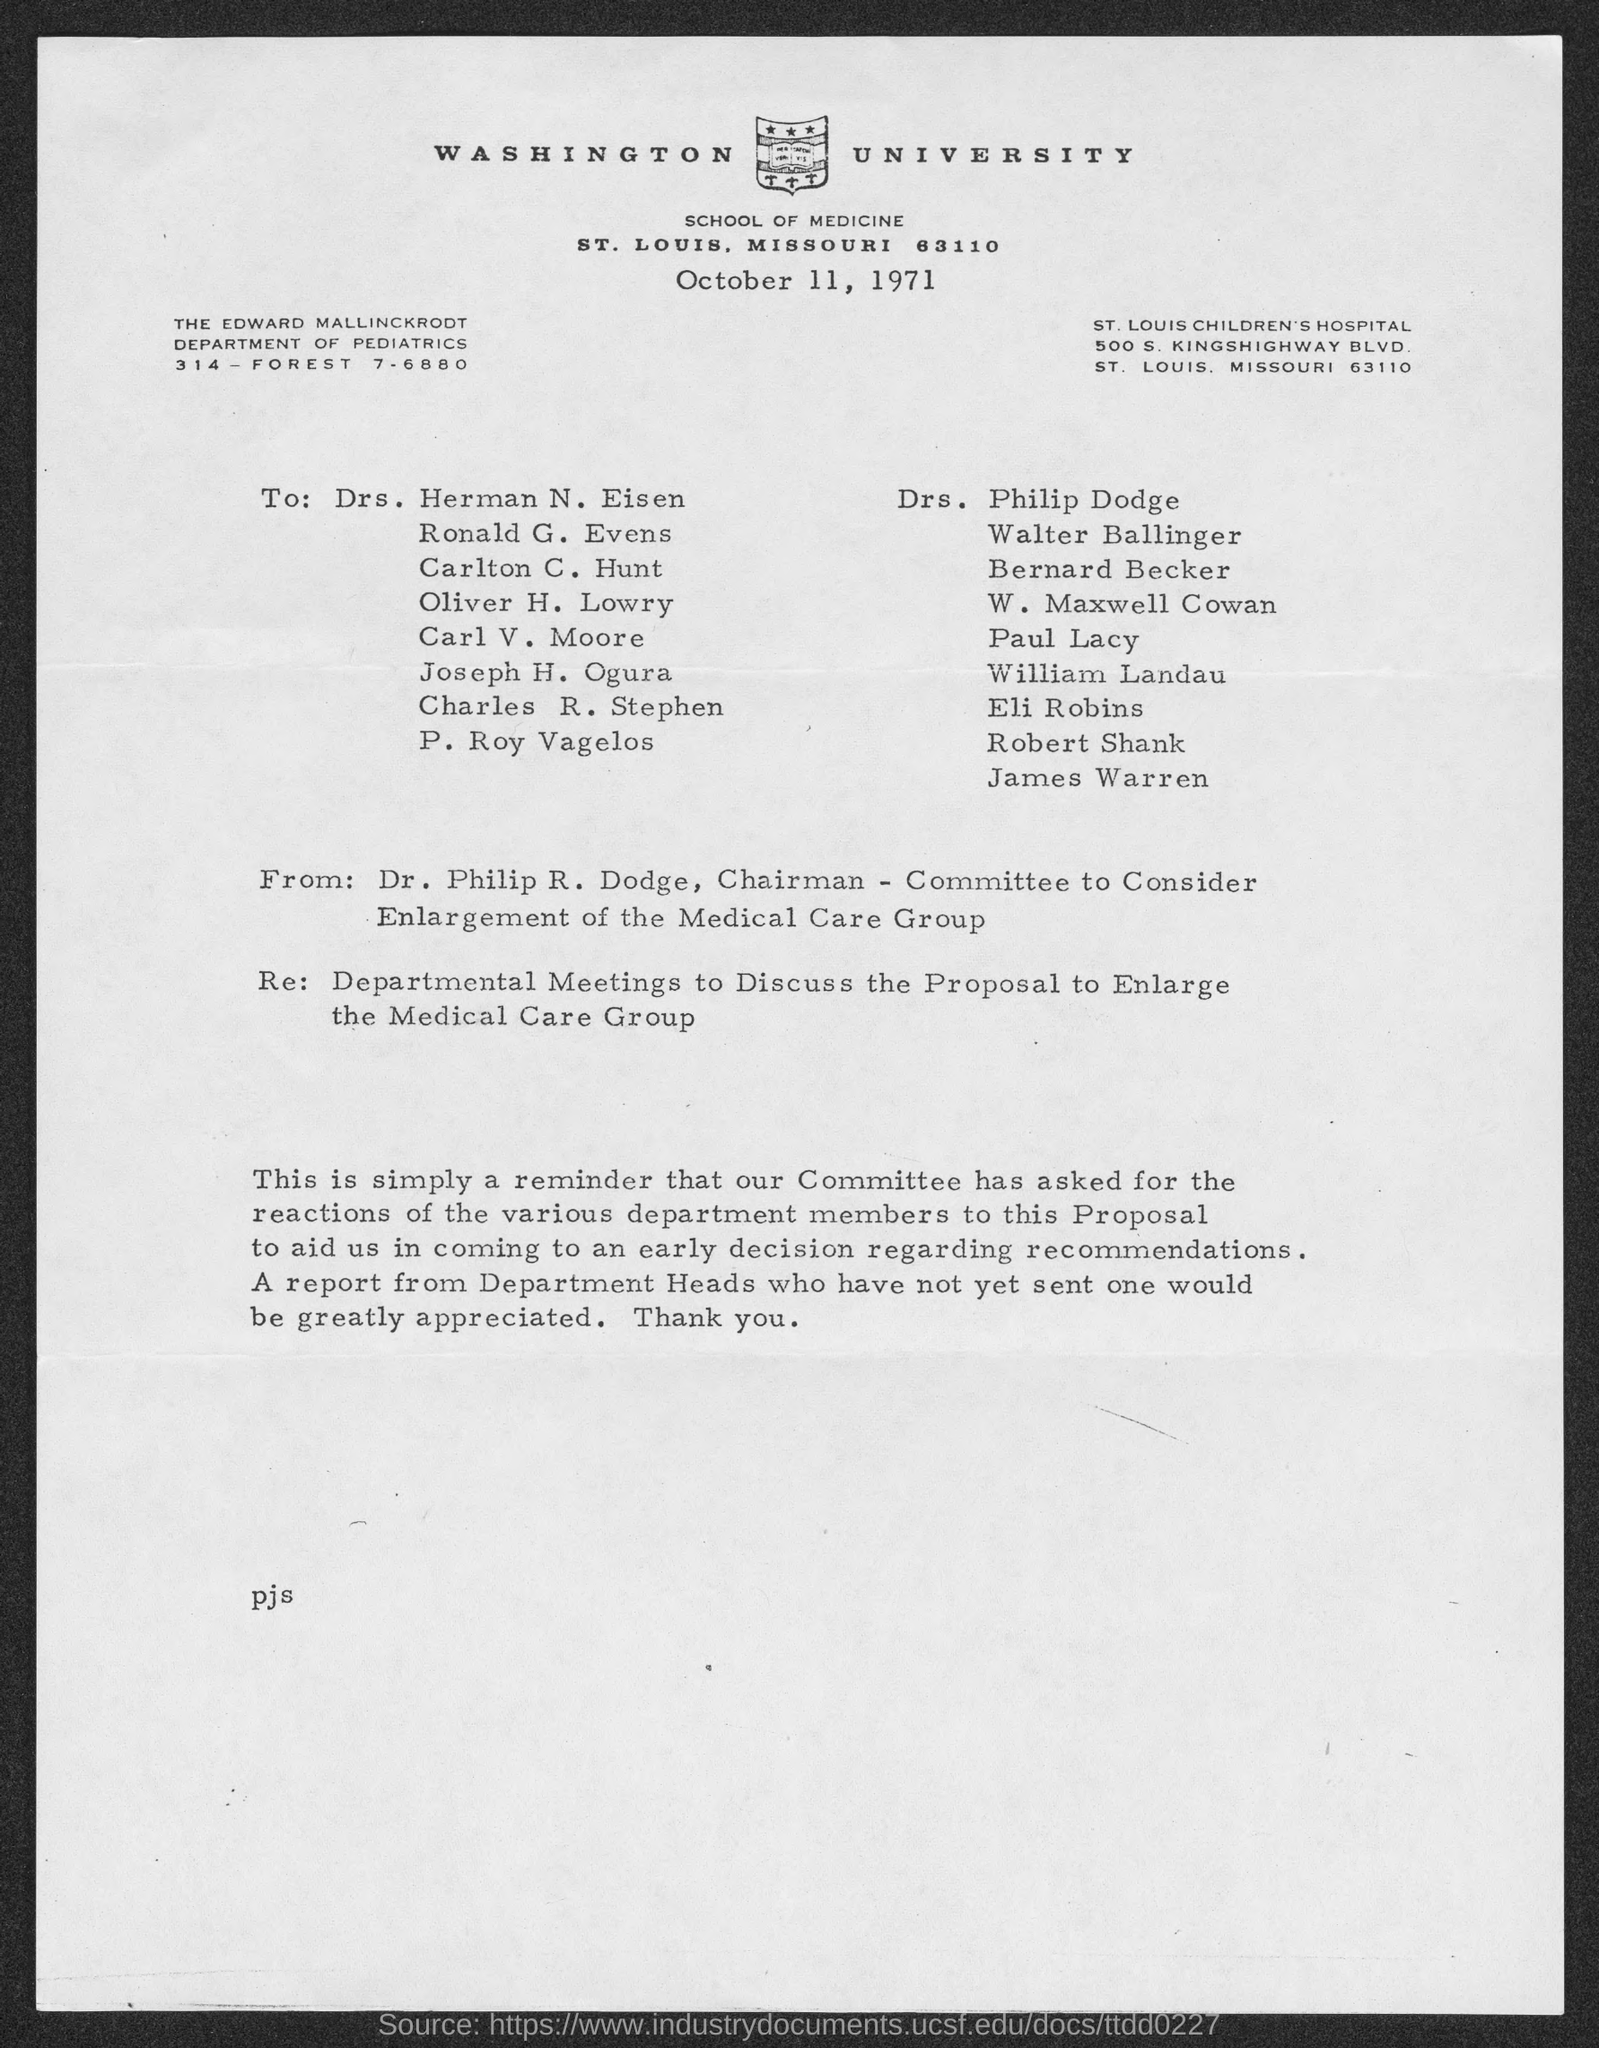What is the date on the document?
Ensure brevity in your answer.  October 11, 1971. Who is this letter from?
Your answer should be very brief. Dr. Philip R. Dodge. 